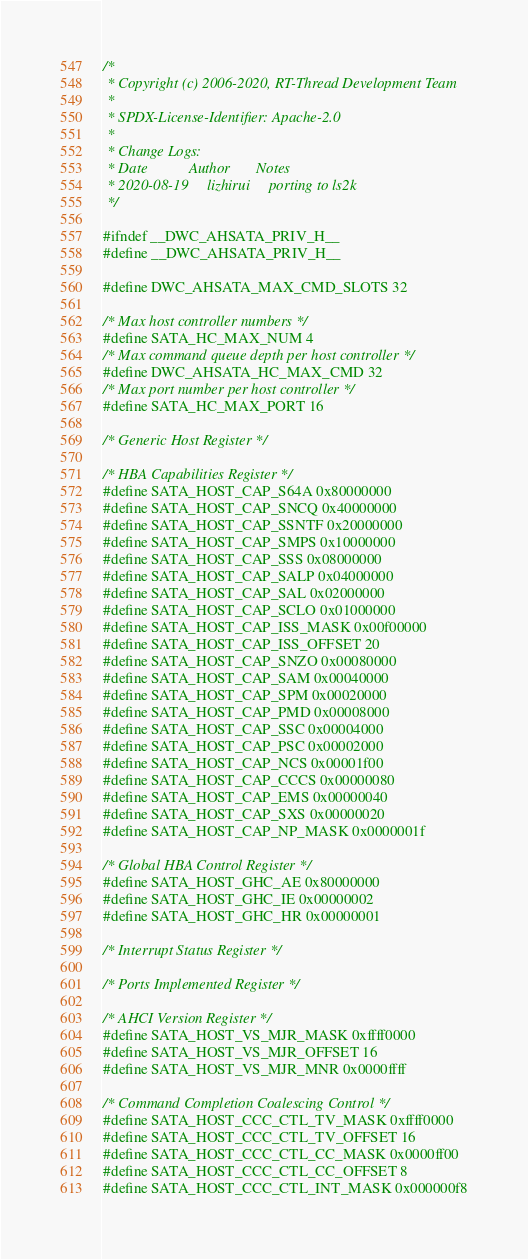<code> <loc_0><loc_0><loc_500><loc_500><_C_>/*
 * Copyright (c) 2006-2020, RT-Thread Development Team
 *
 * SPDX-License-Identifier: Apache-2.0
 *
 * Change Logs:
 * Date           Author       Notes
 * 2020-08-19     lizhirui     porting to ls2k
 */

#ifndef __DWC_AHSATA_PRIV_H__
#define __DWC_AHSATA_PRIV_H__

#define DWC_AHSATA_MAX_CMD_SLOTS 32

/* Max host controller numbers */
#define SATA_HC_MAX_NUM 4
/* Max command queue depth per host controller */
#define DWC_AHSATA_HC_MAX_CMD 32
/* Max port number per host controller */
#define SATA_HC_MAX_PORT 16

/* Generic Host Register */

/* HBA Capabilities Register */
#define SATA_HOST_CAP_S64A 0x80000000
#define SATA_HOST_CAP_SNCQ 0x40000000
#define SATA_HOST_CAP_SSNTF 0x20000000
#define SATA_HOST_CAP_SMPS 0x10000000
#define SATA_HOST_CAP_SSS 0x08000000
#define SATA_HOST_CAP_SALP 0x04000000
#define SATA_HOST_CAP_SAL 0x02000000
#define SATA_HOST_CAP_SCLO 0x01000000
#define SATA_HOST_CAP_ISS_MASK 0x00f00000
#define SATA_HOST_CAP_ISS_OFFSET 20
#define SATA_HOST_CAP_SNZO 0x00080000
#define SATA_HOST_CAP_SAM 0x00040000
#define SATA_HOST_CAP_SPM 0x00020000
#define SATA_HOST_CAP_PMD 0x00008000
#define SATA_HOST_CAP_SSC 0x00004000
#define SATA_HOST_CAP_PSC 0x00002000
#define SATA_HOST_CAP_NCS 0x00001f00
#define SATA_HOST_CAP_CCCS 0x00000080
#define SATA_HOST_CAP_EMS 0x00000040
#define SATA_HOST_CAP_SXS 0x00000020
#define SATA_HOST_CAP_NP_MASK 0x0000001f

/* Global HBA Control Register */
#define SATA_HOST_GHC_AE 0x80000000
#define SATA_HOST_GHC_IE 0x00000002
#define SATA_HOST_GHC_HR 0x00000001

/* Interrupt Status Register */

/* Ports Implemented Register */

/* AHCI Version Register */
#define SATA_HOST_VS_MJR_MASK 0xffff0000
#define SATA_HOST_VS_MJR_OFFSET 16
#define SATA_HOST_VS_MJR_MNR 0x0000ffff

/* Command Completion Coalescing Control */
#define SATA_HOST_CCC_CTL_TV_MASK 0xffff0000
#define SATA_HOST_CCC_CTL_TV_OFFSET 16
#define SATA_HOST_CCC_CTL_CC_MASK 0x0000ff00
#define SATA_HOST_CCC_CTL_CC_OFFSET 8
#define SATA_HOST_CCC_CTL_INT_MASK 0x000000f8</code> 